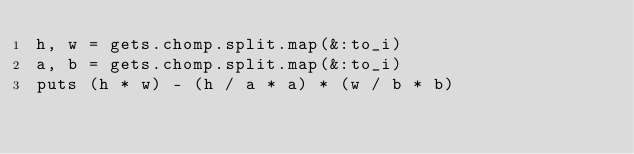Convert code to text. <code><loc_0><loc_0><loc_500><loc_500><_Ruby_>h, w = gets.chomp.split.map(&:to_i)
a, b = gets.chomp.split.map(&:to_i)
puts (h * w) - (h / a * a) * (w / b * b)
</code> 